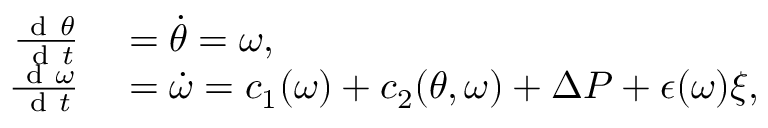Convert formula to latex. <formula><loc_0><loc_0><loc_500><loc_500>\begin{array} { r l } { \frac { d \theta } { d t } } & = \dot { \theta } = \omega , } \\ { \frac { d \omega } { d t } } & = \dot { \omega } = c _ { 1 } ( \omega ) + c _ { 2 } ( \theta , \omega ) + \Delta P + \epsilon ( \omega ) \xi , } \end{array}</formula> 